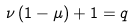<formula> <loc_0><loc_0><loc_500><loc_500>\nu \left ( 1 - \mu \right ) + 1 = q</formula> 